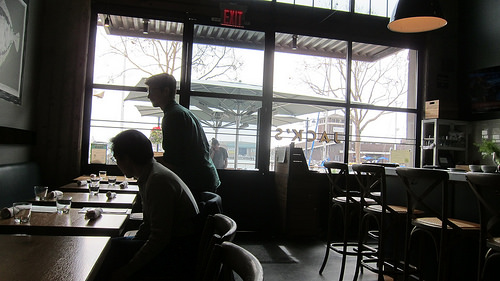<image>
Is the man next to the chair? No. The man is not positioned next to the chair. They are located in different areas of the scene. 